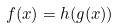<formula> <loc_0><loc_0><loc_500><loc_500>f ( x ) = h ( g ( x ) )</formula> 